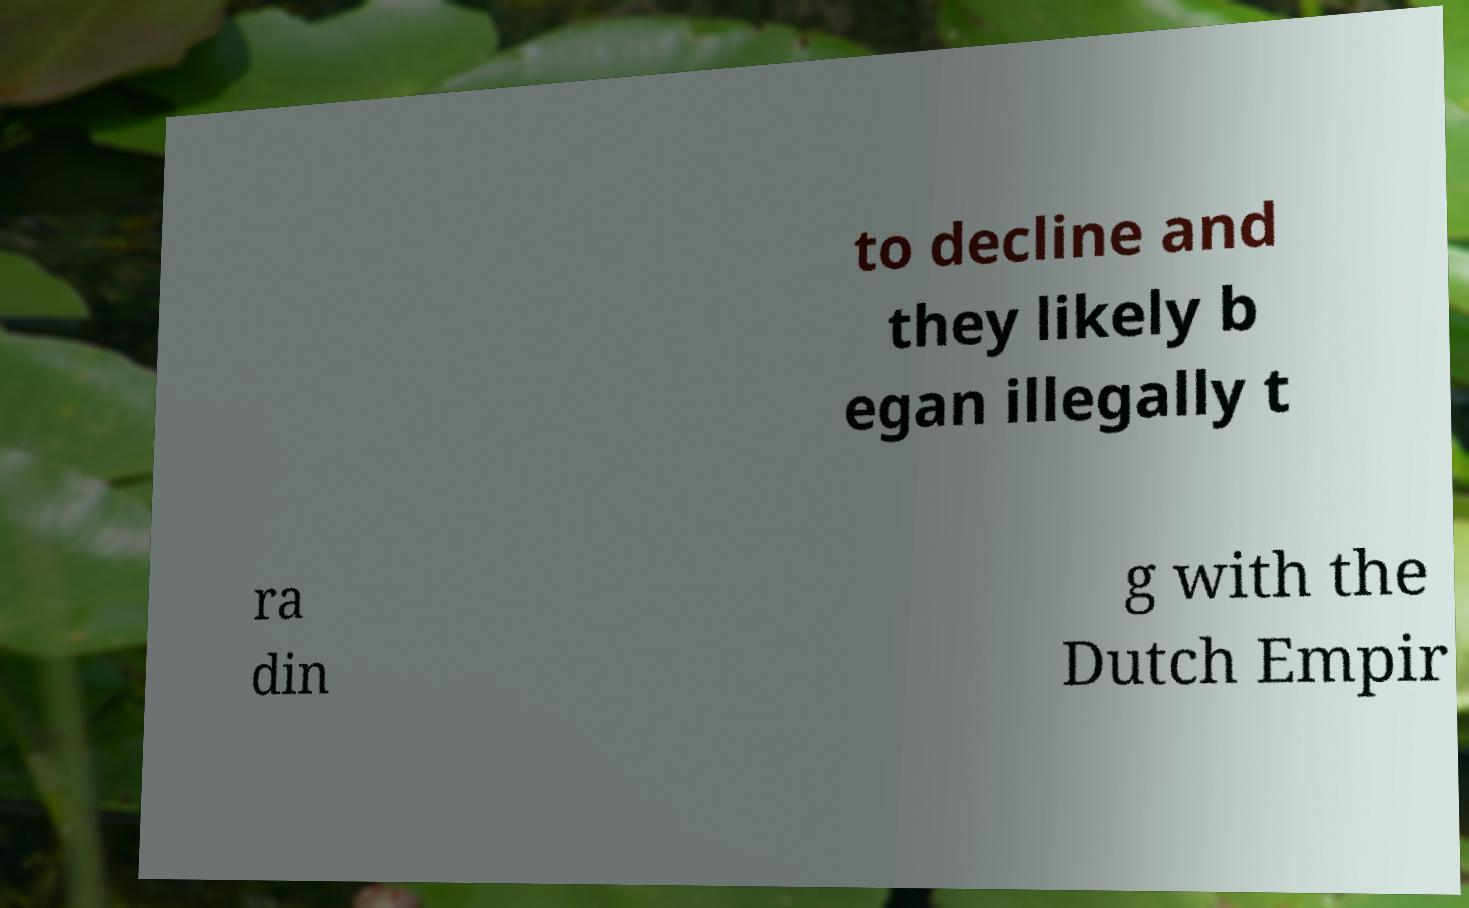Could you assist in decoding the text presented in this image and type it out clearly? to decline and they likely b egan illegally t ra din g with the Dutch Empir 